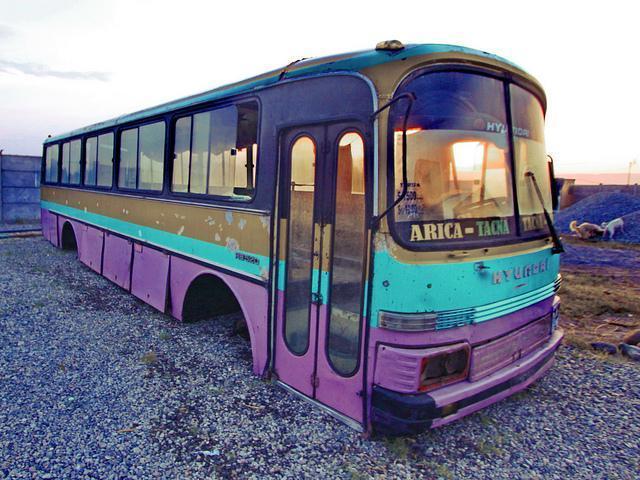How many buses are there?
Give a very brief answer. 1. 